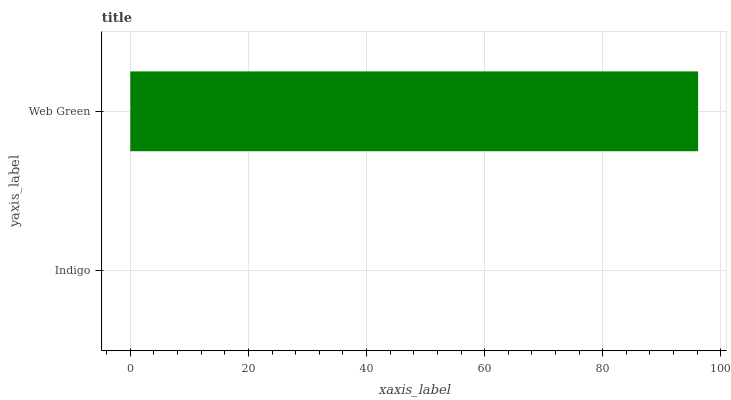Is Indigo the minimum?
Answer yes or no. Yes. Is Web Green the maximum?
Answer yes or no. Yes. Is Web Green the minimum?
Answer yes or no. No. Is Web Green greater than Indigo?
Answer yes or no. Yes. Is Indigo less than Web Green?
Answer yes or no. Yes. Is Indigo greater than Web Green?
Answer yes or no. No. Is Web Green less than Indigo?
Answer yes or no. No. Is Web Green the high median?
Answer yes or no. Yes. Is Indigo the low median?
Answer yes or no. Yes. Is Indigo the high median?
Answer yes or no. No. Is Web Green the low median?
Answer yes or no. No. 